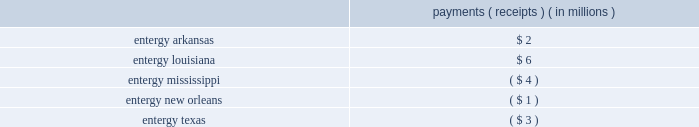Entergy corporation and subsidiaries notes to financial statements the ferc proceedings that resulted from rate filings made in 2007 , 2008 , and 2009 have been resolved by various orders issued by the ferc and appellate courts .
See below for a discussion of rate filings since 2009 and the comprehensive recalculation filing directed by the ferc in the proceeding related to the 2010 rate filing .
2010 rate filing based on calendar year 2009 production costs in may 2010 , entergy filed with the ferc the 2010 rates in accordance with the ferc 2019s orders in the system agreement proceeding , and supplemented the filing in september 2010 .
Several parties intervened in the proceeding at the ferc , including the lpsc and the city council , which also filed protests .
In july 2010 the ferc accepted entergy 2019s proposed rates for filing , effective june 1 , 2010 , subject to refund , and set the proceeding for hearing and settlement procedures .
Settlement procedures have been terminated , and the alj scheduled hearings to begin in march 2011 .
Subsequently , in january 2011 the alj issued an order directing the parties and ferc staff to show cause why this proceeding should not be stayed pending the issuance of ferc decisions in the prior production cost proceedings currently before the ferc on review .
In march 2011 the alj issued an order placing this proceeding in abeyance .
In october 2013 the ferc issued an order granting clarification and denying rehearing with respect to its october 2011 rehearing order in this proceeding .
The ferc clarified that in a bandwidth proceeding parties can challenge erroneous inputs , implementation errors , or prudence of cost inputs , but challenges to the bandwidth formula itself must be raised in a federal power act section 206 complaint or section 205 filing .
Subsequently in october 2013 the presiding alj lifted the stay order holding in abeyance the hearing previously ordered by the ferc and directing that the remaining issues proceed to a hearing on the merits .
The hearing was held in march 2014 and the presiding alj issued an initial decision in september 2014 .
Briefs on exception were filed in october 2014 .
In december 2015 the ferc issued an order affirming the initial decision in part and rejecting the initial decision in part .
Among other things , the december 2015 order directs entergy services to submit a compliance filing , the results of which may affect the rough production cost equalization filings made for the june - december 2005 , 2006 , 2007 , and 2008 test periods .
In january 2016 the lpsc , the apsc , and entergy services filed requests for rehearing of the ferc 2019s december 2015 order .
In february 2016 , entergy services submitted the compliance filing ordered in the december 2015 order .
The result of the true-up payments and receipts for the recalculation of production costs resulted in the following payments/receipts among the utility operating companies : payments ( receipts ) ( in millions ) .
2011 rate filing based on calendar year 2010 production costs in may 2011 , entergy filed with the ferc the 2011 rates in accordance with the ferc 2019s orders in the system agreement proceeding .
Several parties intervened in the proceeding at the ferc , including the lpsc , which also filed a protest .
In july 2011 the ferc accepted entergy 2019s proposed rates for filing , effective june 1 , 2011 , subject to refund , set the proceeding for hearing procedures , and then held those procedures in abeyance pending ferc decisions in the prior production cost proceedings currently before the ferc on review .
In january 2014 the lpsc filed a petition for a writ of mandamus at the united states court of appeals for the fifth circuit .
In its petition , the lpsc requested that the fifth circuit issue an order compelling the ferc to issue a final order in several proceedings related to the system agreement , including the 2011 rate filing based on calendar year 2010 production costs and the 2012 and 2013 rate filings discussed below .
In march 2014 the fifth circuit rejected the lpsc 2019s petition for a writ of mandamus .
In december 2014 the ferc rescinded its earlier abeyance order and consolidated the 2011 rate filing with the 2012 , 2013 .
What is the difference in payments between entergy louisiana and entergy arkansas , in millions? 
Computations: (6 - 2)
Answer: 4.0. 